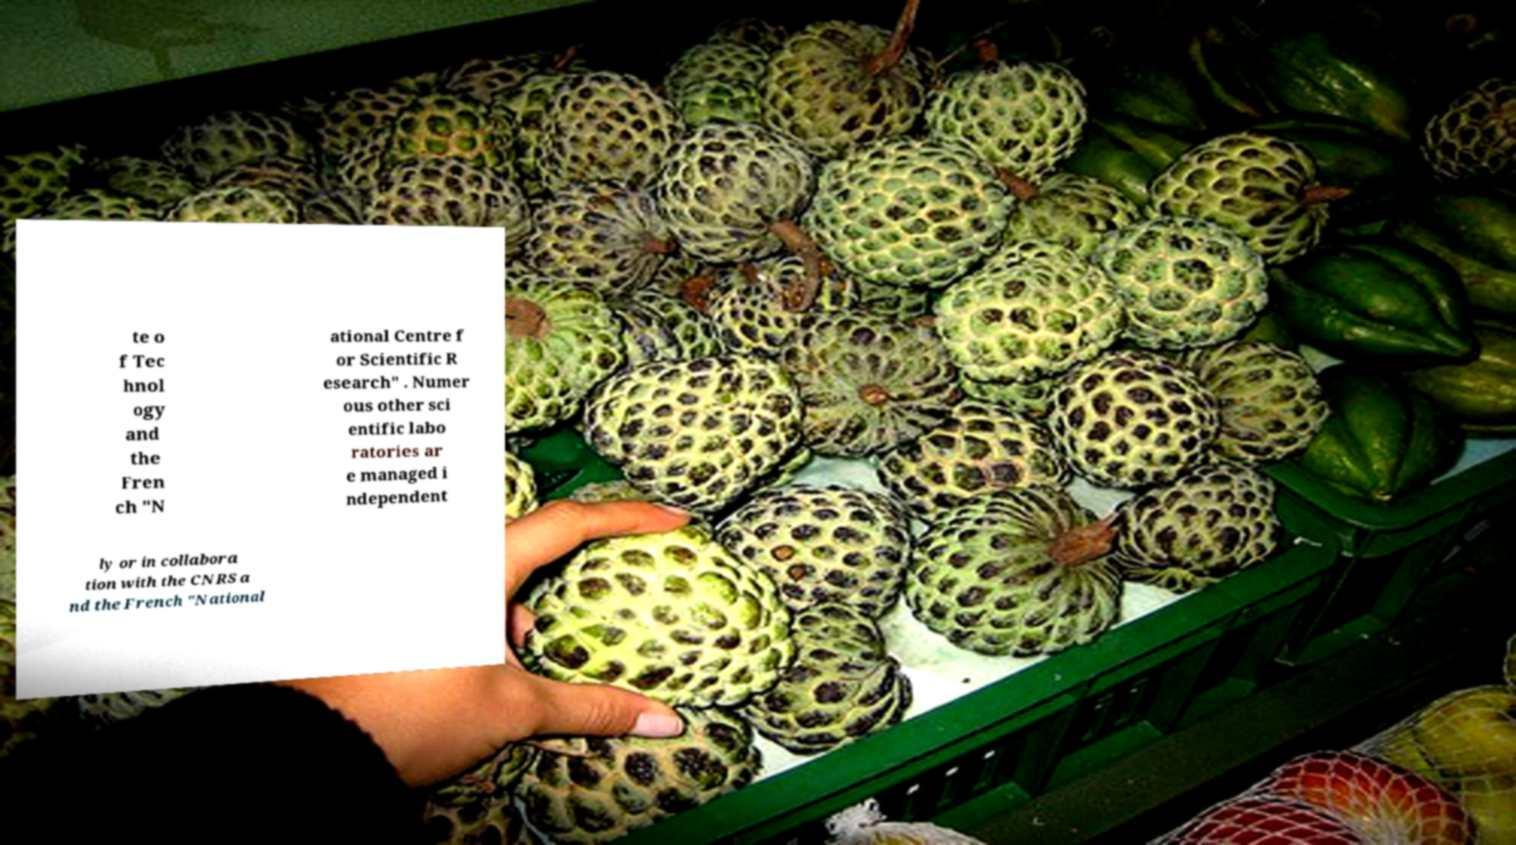I need the written content from this picture converted into text. Can you do that? te o f Tec hnol ogy and the Fren ch "N ational Centre f or Scientific R esearch" . Numer ous other sci entific labo ratories ar e managed i ndependent ly or in collabora tion with the CNRS a nd the French "National 